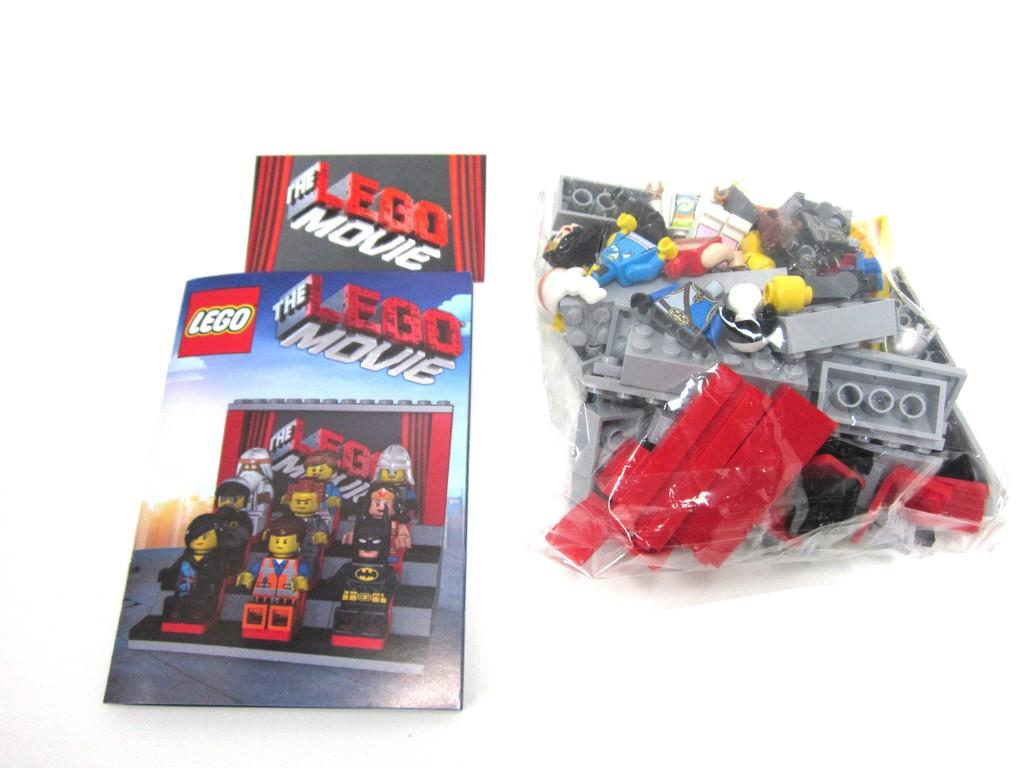What objects are contained within the packet in the image? There are toys in a packet in the image. What is located on the platform in the image? There are cards on a platform in the image. What type of root can be seen growing from the toys in the image? There is no root growing from the toys in the image. What might be used to cut the cards on the platform in the image? The image does not show any scissors or cutting tools, so it cannot be determined what might be used to cut the cards. What type of snack is visible in the image? There is no snack, such as popcorn, present in the image. 